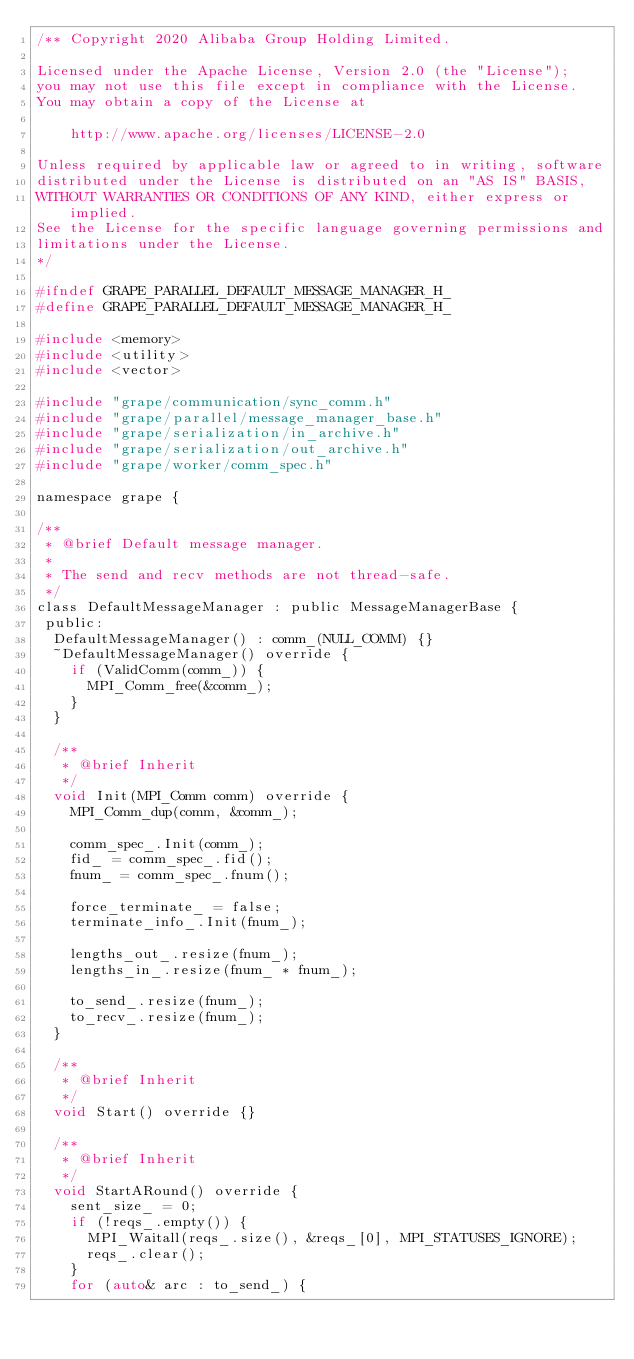Convert code to text. <code><loc_0><loc_0><loc_500><loc_500><_C_>/** Copyright 2020 Alibaba Group Holding Limited.

Licensed under the Apache License, Version 2.0 (the "License");
you may not use this file except in compliance with the License.
You may obtain a copy of the License at

    http://www.apache.org/licenses/LICENSE-2.0

Unless required by applicable law or agreed to in writing, software
distributed under the License is distributed on an "AS IS" BASIS,
WITHOUT WARRANTIES OR CONDITIONS OF ANY KIND, either express or implied.
See the License for the specific language governing permissions and
limitations under the License.
*/

#ifndef GRAPE_PARALLEL_DEFAULT_MESSAGE_MANAGER_H_
#define GRAPE_PARALLEL_DEFAULT_MESSAGE_MANAGER_H_

#include <memory>
#include <utility>
#include <vector>

#include "grape/communication/sync_comm.h"
#include "grape/parallel/message_manager_base.h"
#include "grape/serialization/in_archive.h"
#include "grape/serialization/out_archive.h"
#include "grape/worker/comm_spec.h"

namespace grape {

/**
 * @brief Default message manager.
 *
 * The send and recv methods are not thread-safe.
 */
class DefaultMessageManager : public MessageManagerBase {
 public:
  DefaultMessageManager() : comm_(NULL_COMM) {}
  ~DefaultMessageManager() override {
    if (ValidComm(comm_)) {
      MPI_Comm_free(&comm_);
    }
  }

  /**
   * @brief Inherit
   */
  void Init(MPI_Comm comm) override {
    MPI_Comm_dup(comm, &comm_);

    comm_spec_.Init(comm_);
    fid_ = comm_spec_.fid();
    fnum_ = comm_spec_.fnum();

    force_terminate_ = false;
    terminate_info_.Init(fnum_);

    lengths_out_.resize(fnum_);
    lengths_in_.resize(fnum_ * fnum_);

    to_send_.resize(fnum_);
    to_recv_.resize(fnum_);
  }

  /**
   * @brief Inherit
   */
  void Start() override {}

  /**
   * @brief Inherit
   */
  void StartARound() override {
    sent_size_ = 0;
    if (!reqs_.empty()) {
      MPI_Waitall(reqs_.size(), &reqs_[0], MPI_STATUSES_IGNORE);
      reqs_.clear();
    }
    for (auto& arc : to_send_) {</code> 